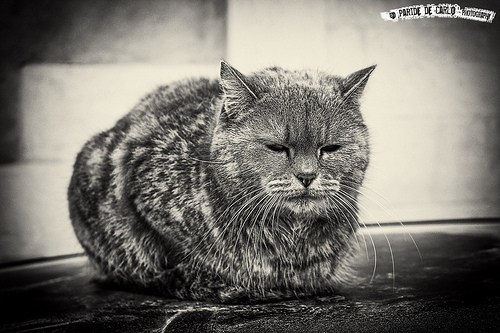<image>
Is there a whiskers above the floor? Yes. The whiskers is positioned above the floor in the vertical space, higher up in the scene. 